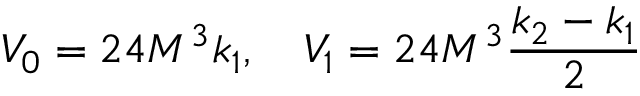<formula> <loc_0><loc_0><loc_500><loc_500>V _ { 0 } = 2 4 M ^ { 3 } k _ { 1 } , V _ { 1 } = 2 4 M ^ { 3 } \frac { k _ { 2 } - k _ { 1 } } { 2 }</formula> 